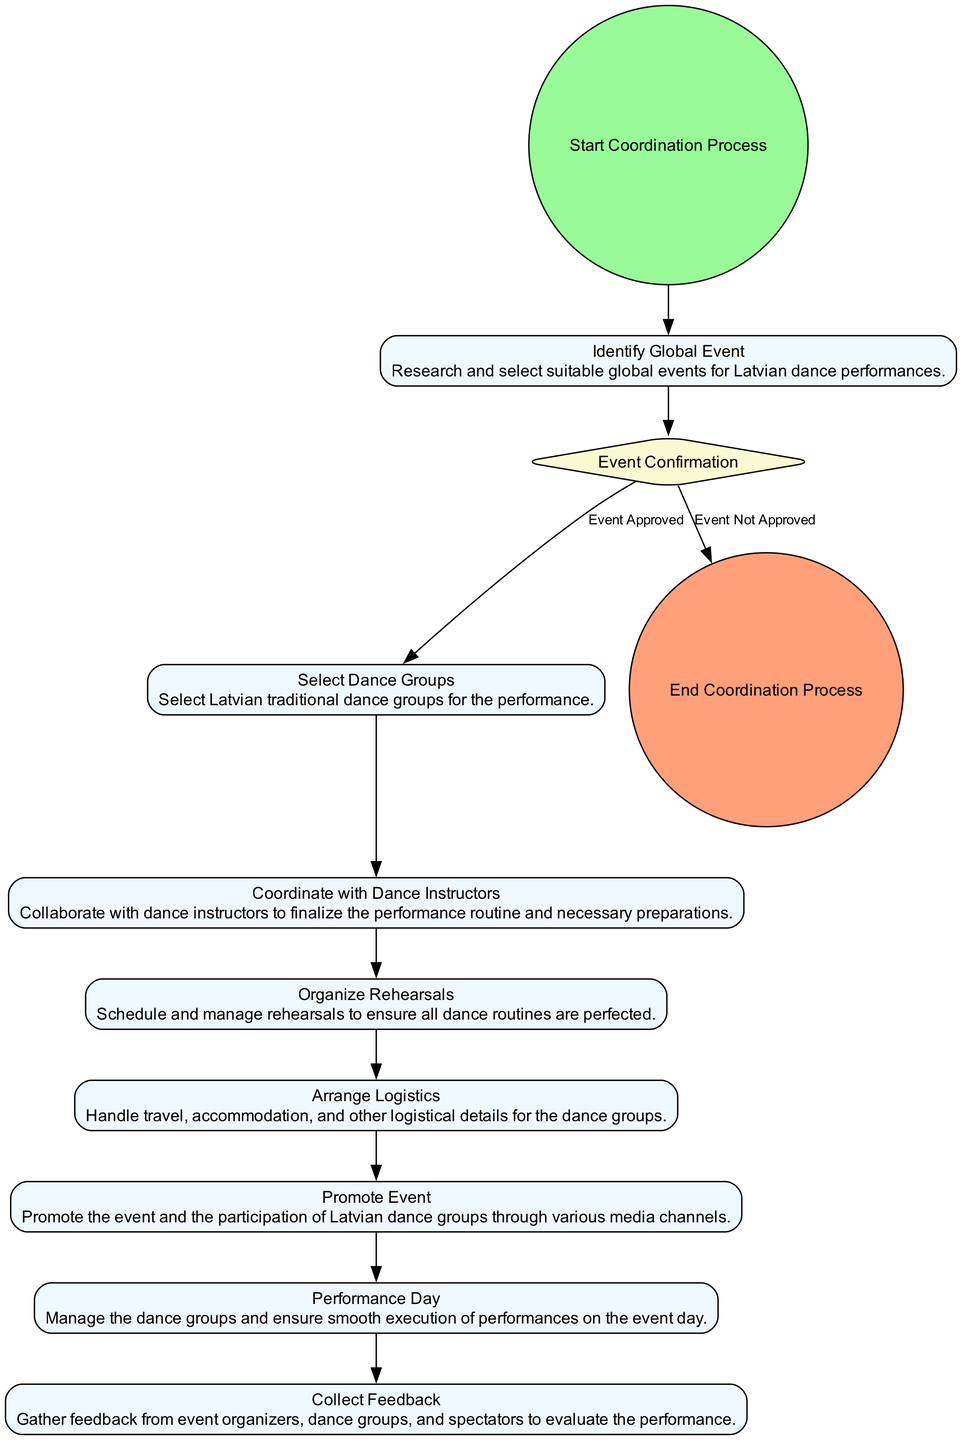What is the first action in the coordination process? The diagram starts with the "Identify Global Event" action, which is the first step in the process of coordinating Latvian traditional dance performances.
Answer: Identify Global Event How many actions are there in the diagram? By counting all the action elements from the diagram, there are 6 actions present, which are "Identify Global Event," "Select Dance Groups," "Coordinate with Dance Instructors," "Organize Rehearsals," "Arrange Logistics," and "Promote Event."
Answer: 6 What happens if the event is not approved? If the event is not approved, the flow of the diagram indicates that it leads directly to the "End Coordination Process" node, meaning no further actions are taken.
Answer: End Coordination Process What is required after selecting dance groups? After selecting the dance groups, the next action in the diagram is "Coordinate with Dance Instructors," indicating that collaboration with the instructors is the next required step.
Answer: Coordinate with Dance Instructors How many branches does the decision node "Event Confirmation" have? The "Event Confirmation" node has 2 branches based on whether the event is approved or not, which are "Event Approved" and "Event Not Approved."
Answer: 2 What is the final action before the coordination process ends? Before reaching the "End Coordination Process," the last action shown in the diagram is "Collect Feedback," which occurs after the performance day.
Answer: Collect Feedback Which action involves promoting the event? The action that specifically deals with promoting the event within the diagram is "Promote Event," which focuses on raising awareness through media channels.
Answer: Promote Event What is the relationship between "Organize Rehearsals" and "Performance Day"? The relationship indicates a sequential flow where "Organize Rehearsals" must occur before "Performance Day," meaning rehearsals must be completed prior to the actual performance.
Answer: Sequential flow How does the coordination process begin? The coordination process begins with the "Start Coordination Process" node, indicating the initiation of the activity diagram.
Answer: Start Coordination Process 